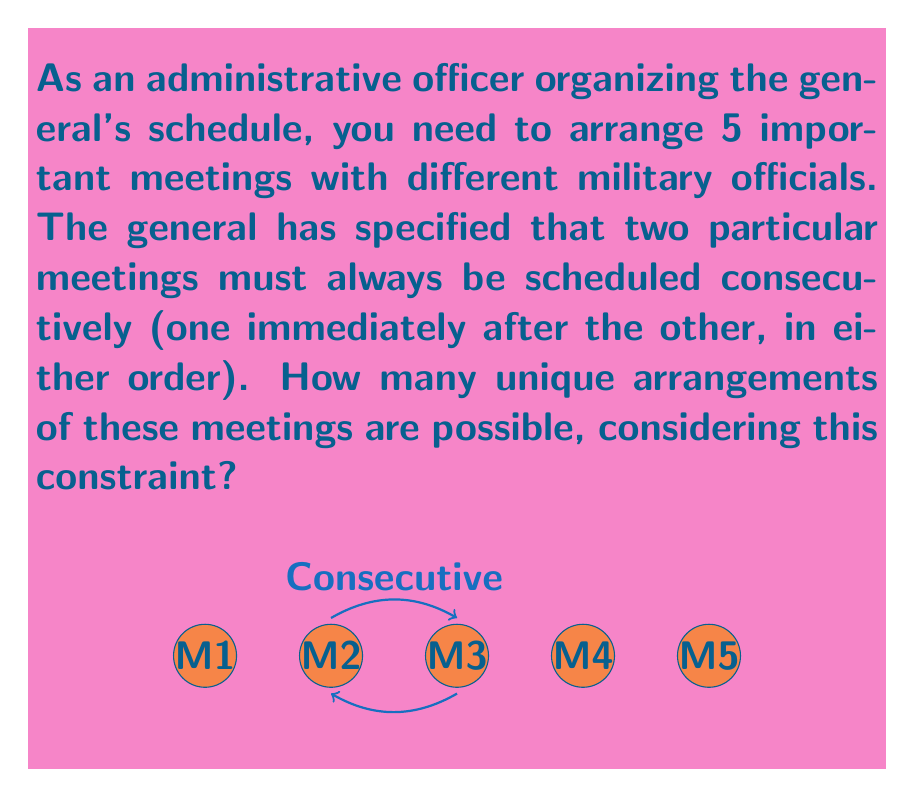Could you help me with this problem? Let's approach this problem using group theory concepts:

1) Without any constraints, we would have 5! = 120 possible arrangements.

2) However, the constraint that two meetings must be consecutive reduces our problem to arranging 4 elements: the pair of consecutive meetings (treated as one unit) and the other 3 meetings.

3) We can use the concept of group actions here. Let $G$ be the symmetric group $S_4$ acting on the set of 4 elements (the pair and the other 3 meetings).

4) The number of unique arrangements is equal to $|G| = 4! = 24$.

5) However, we need to account for the fact that the two meetings in the pair can be arranged in 2! = 2 ways.

6) By the multiplication principle, the total number of unique arrangements is:

   $$24 \times 2 = 48$$

This result can be interpreted as follows:
- We have 4! ways to arrange the 4 elements (the pair and the other 3 meetings).
- For each of these arrangements, we have 2! ways to arrange the meetings within the pair.

Therefore, the total number of unique arrangements is 48.
Answer: 48 